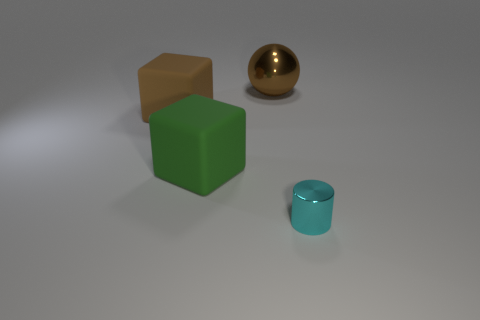There is a brown cube that is the same size as the sphere; what is its material?
Provide a succinct answer. Rubber. What number of other things are there of the same material as the big brown block
Provide a short and direct response. 1. Are there the same number of rubber cubes in front of the brown rubber thing and shiny objects that are to the left of the large brown sphere?
Make the answer very short. No. How many brown objects are either matte objects or big shiny things?
Provide a short and direct response. 2. Is the color of the cylinder the same as the metallic thing that is on the left side of the tiny object?
Keep it short and to the point. No. What number of other objects are there of the same color as the tiny metallic thing?
Your answer should be compact. 0. Are there fewer big matte blocks than small yellow shiny cylinders?
Your response must be concise. No. There is a metal thing that is in front of the metallic thing that is on the left side of the cylinder; what number of tiny cyan objects are in front of it?
Your response must be concise. 0. There is a metal object that is to the left of the small metal cylinder; how big is it?
Your answer should be compact. Large. Does the brown thing that is on the left side of the brown shiny object have the same shape as the green rubber object?
Your answer should be compact. Yes. 